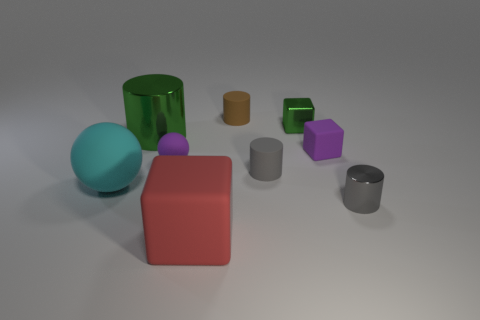There is a tiny gray rubber thing; is its shape the same as the small purple object that is left of the large red cube?
Provide a short and direct response. No. Is there any other thing that has the same material as the big red thing?
Your response must be concise. Yes. There is a tiny brown object that is the same shape as the big shiny object; what is its material?
Offer a very short reply. Rubber. What number of tiny objects are balls or metallic objects?
Offer a very short reply. 3. Are there fewer shiny things in front of the small gray rubber thing than large blocks on the left side of the gray metal object?
Keep it short and to the point. No. What number of objects are big cyan rubber spheres or rubber balls?
Give a very brief answer. 2. What number of red matte cubes are behind the brown rubber cylinder?
Provide a short and direct response. 0. Is the tiny metal cube the same color as the large cylinder?
Your answer should be very brief. Yes. The gray object that is made of the same material as the purple ball is what shape?
Your answer should be compact. Cylinder. Is the shape of the green metal object that is left of the tiny gray rubber cylinder the same as  the gray metallic object?
Provide a succinct answer. Yes. 